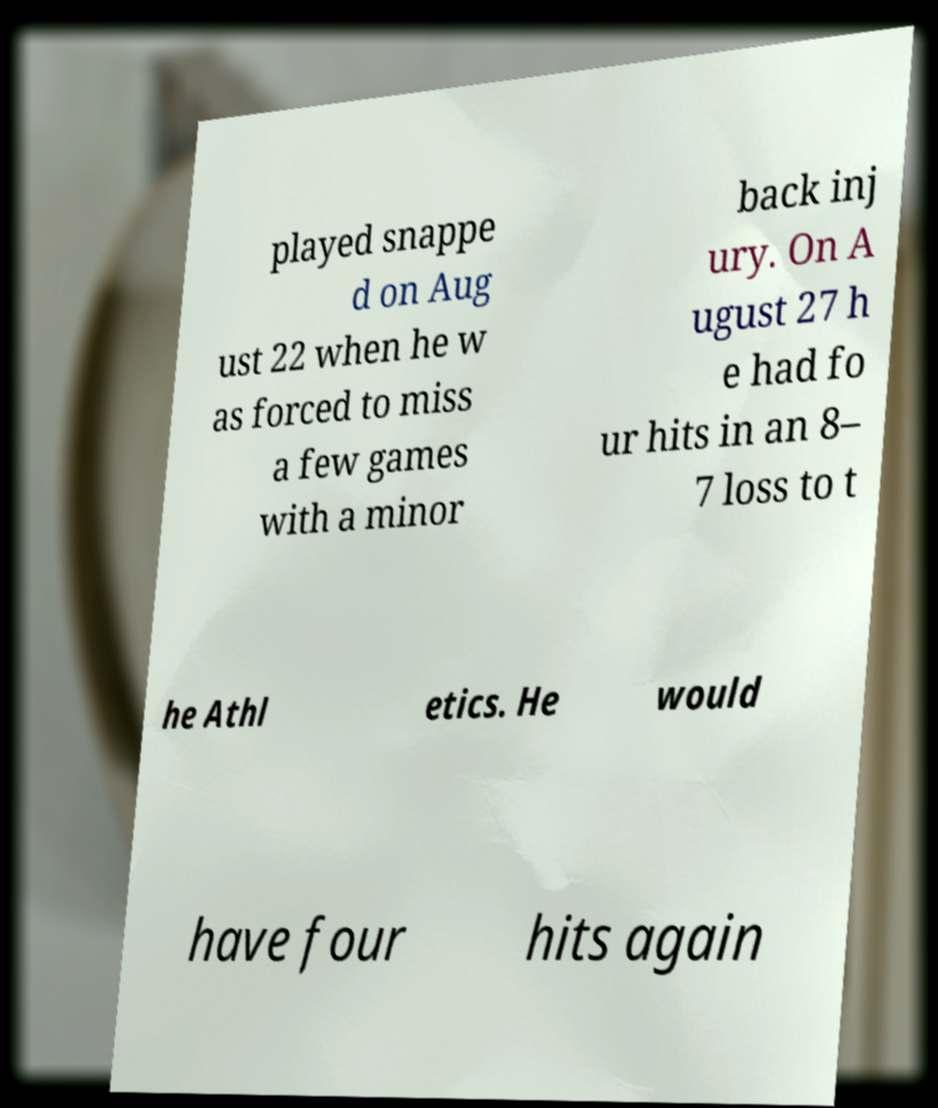What messages or text are displayed in this image? I need them in a readable, typed format. played snappe d on Aug ust 22 when he w as forced to miss a few games with a minor back inj ury. On A ugust 27 h e had fo ur hits in an 8– 7 loss to t he Athl etics. He would have four hits again 